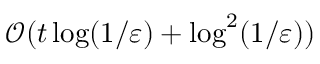Convert formula to latex. <formula><loc_0><loc_0><loc_500><loc_500>\mathcal { O } ( t \log ( 1 / \varepsilon ) + \log ^ { 2 } ( 1 / \varepsilon ) )</formula> 